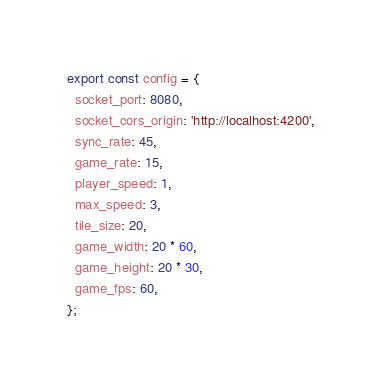Convert code to text. <code><loc_0><loc_0><loc_500><loc_500><_TypeScript_>export const config = {
  socket_port: 8080,
  socket_cors_origin: 'http://localhost:4200',
  sync_rate: 45,
  game_rate: 15,
  player_speed: 1,
  max_speed: 3,
  tile_size: 20,
  game_width: 20 * 60,
  game_height: 20 * 30,
  game_fps: 60,
};
</code> 